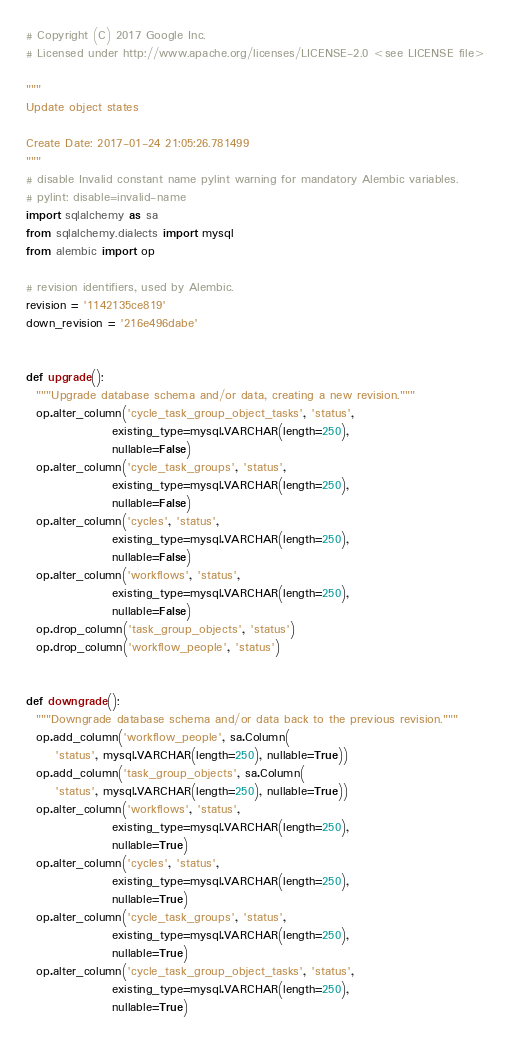<code> <loc_0><loc_0><loc_500><loc_500><_Python_># Copyright (C) 2017 Google Inc.
# Licensed under http://www.apache.org/licenses/LICENSE-2.0 <see LICENSE file>

"""
Update object states

Create Date: 2017-01-24 21:05:26.781499
"""
# disable Invalid constant name pylint warning for mandatory Alembic variables.
# pylint: disable=invalid-name
import sqlalchemy as sa
from sqlalchemy.dialects import mysql
from alembic import op

# revision identifiers, used by Alembic.
revision = '1142135ce819'
down_revision = '216e496dabe'


def upgrade():
  """Upgrade database schema and/or data, creating a new revision."""
  op.alter_column('cycle_task_group_object_tasks', 'status',
                  existing_type=mysql.VARCHAR(length=250),
                  nullable=False)
  op.alter_column('cycle_task_groups', 'status',
                  existing_type=mysql.VARCHAR(length=250),
                  nullable=False)
  op.alter_column('cycles', 'status',
                  existing_type=mysql.VARCHAR(length=250),
                  nullable=False)
  op.alter_column('workflows', 'status',
                  existing_type=mysql.VARCHAR(length=250),
                  nullable=False)
  op.drop_column('task_group_objects', 'status')
  op.drop_column('workflow_people', 'status')


def downgrade():
  """Downgrade database schema and/or data back to the previous revision."""
  op.add_column('workflow_people', sa.Column(
      'status', mysql.VARCHAR(length=250), nullable=True))
  op.add_column('task_group_objects', sa.Column(
      'status', mysql.VARCHAR(length=250), nullable=True))
  op.alter_column('workflows', 'status',
                  existing_type=mysql.VARCHAR(length=250),
                  nullable=True)
  op.alter_column('cycles', 'status',
                  existing_type=mysql.VARCHAR(length=250),
                  nullable=True)
  op.alter_column('cycle_task_groups', 'status',
                  existing_type=mysql.VARCHAR(length=250),
                  nullable=True)
  op.alter_column('cycle_task_group_object_tasks', 'status',
                  existing_type=mysql.VARCHAR(length=250),
                  nullable=True)
</code> 